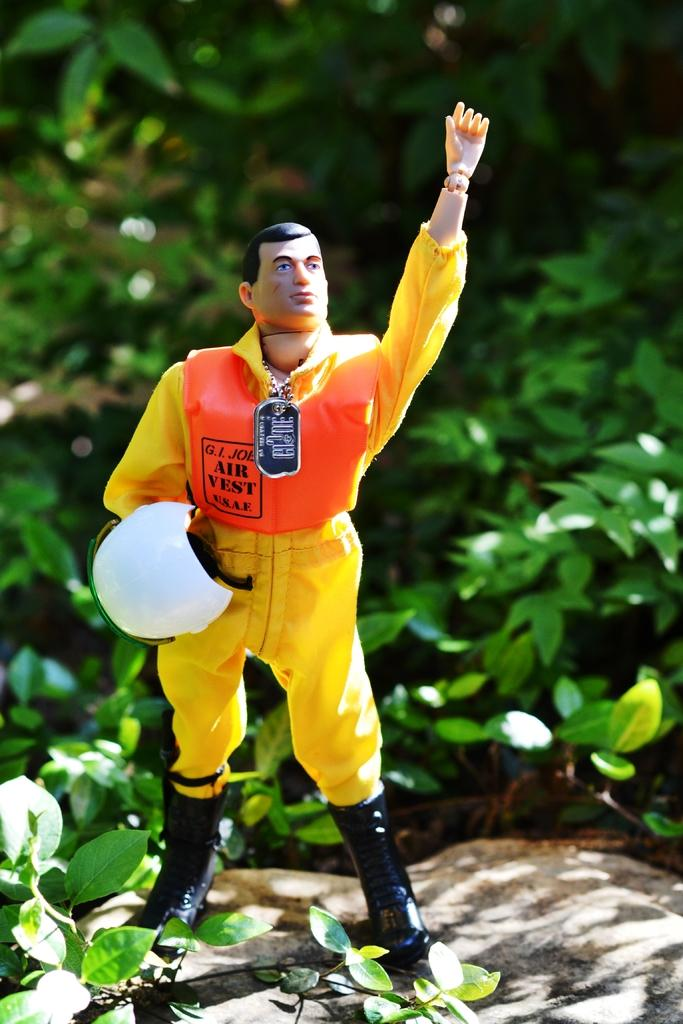What object is present in the image? There is a toy in the image. What is the toy doing with its hand? The toy is raising its hand. What is the toy holding in its other hand? The toy is holding a helmet in its other hand. How would you describe the background of the image? The background of the image is blurry. What type of vegetation can be seen in the background? Leaves are visible in the background of the image. What type of boot is the toy wearing on its foot? The toy is not wearing a boot in the image; it is not mentioned in the provided facts. What type of cloth is the toy made of? The type of cloth the toy is made of is not mentioned in the provided facts. 